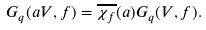Convert formula to latex. <formula><loc_0><loc_0><loc_500><loc_500>G _ { q } ( a V , f ) = \overline { \chi _ { f } } ( a ) G _ { q } ( V , f ) .</formula> 